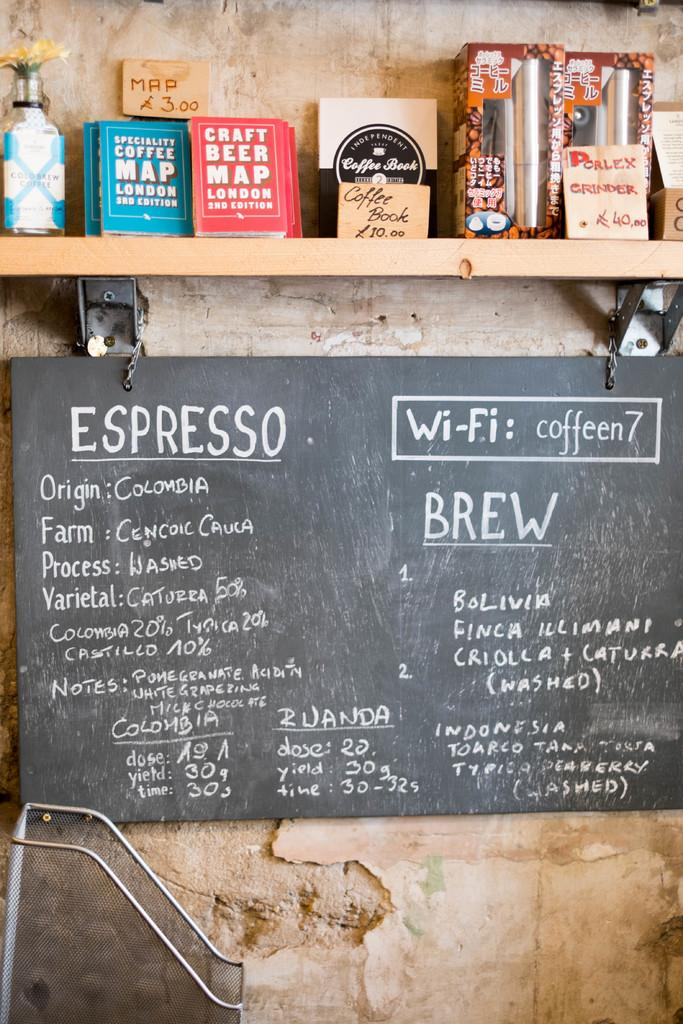<image>
Describe the image concisely. A sign offering different Espresso drinks from Colombia 